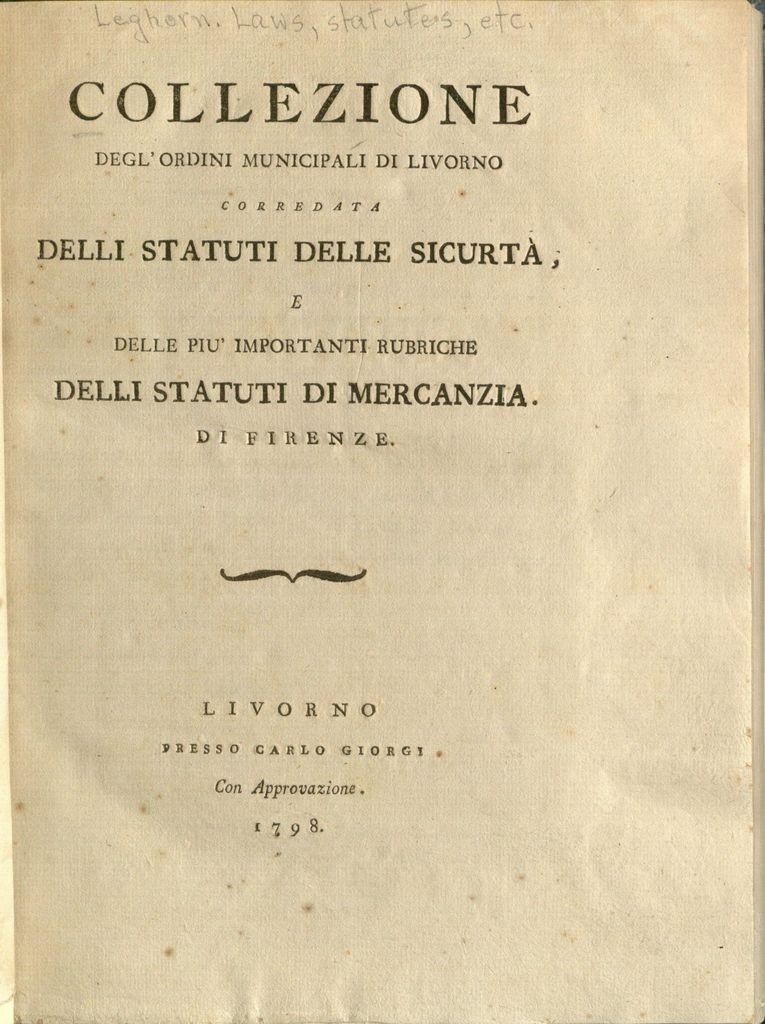<image>
Create a compact narrative representing the image presented. Book page with the word "Collezione" on the top. 